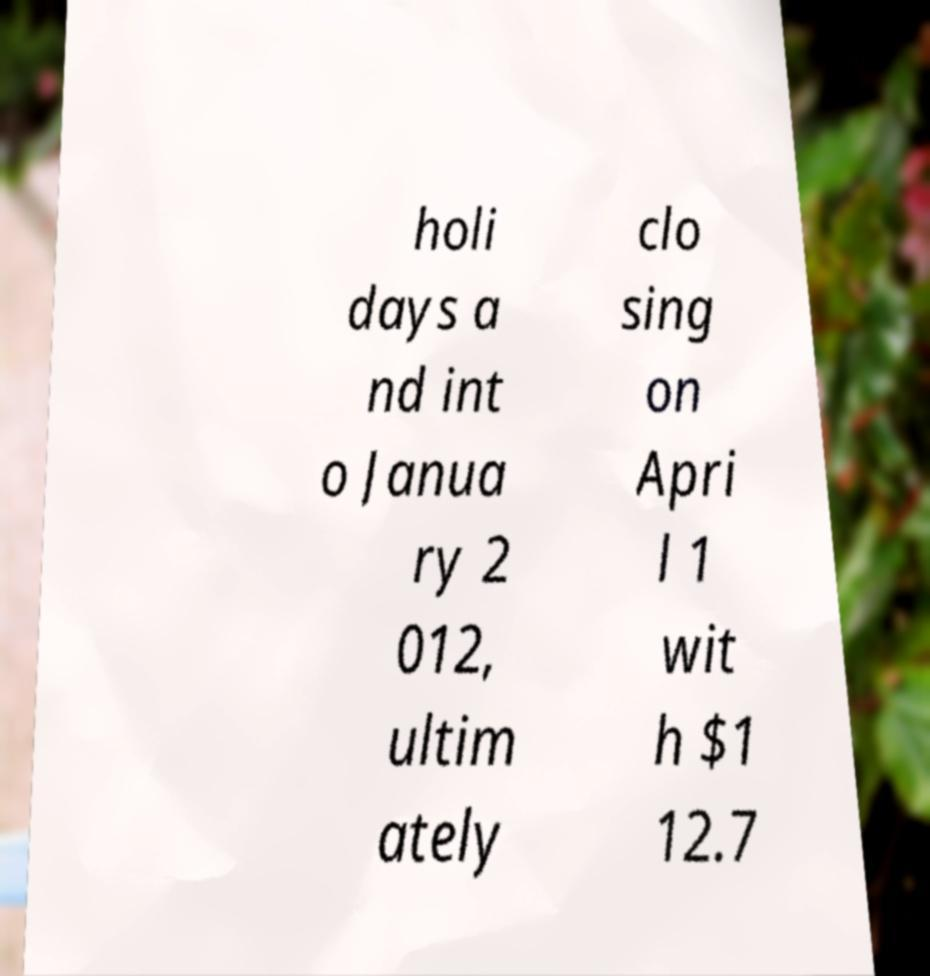Can you accurately transcribe the text from the provided image for me? holi days a nd int o Janua ry 2 012, ultim ately clo sing on Apri l 1 wit h $1 12.7 